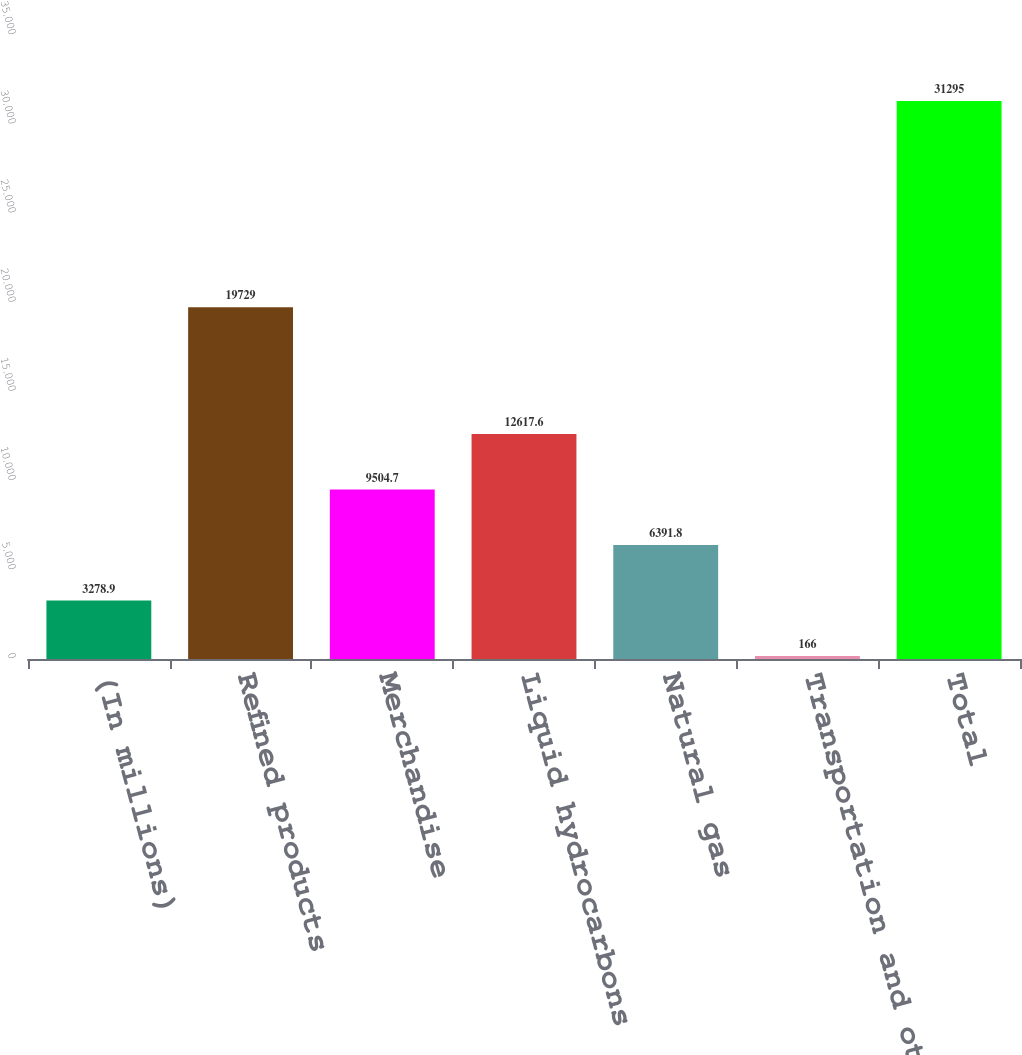Convert chart. <chart><loc_0><loc_0><loc_500><loc_500><bar_chart><fcel>(In millions)<fcel>Refined products<fcel>Merchandise<fcel>Liquid hydrocarbons<fcel>Natural gas<fcel>Transportation and other<fcel>Total<nl><fcel>3278.9<fcel>19729<fcel>9504.7<fcel>12617.6<fcel>6391.8<fcel>166<fcel>31295<nl></chart> 